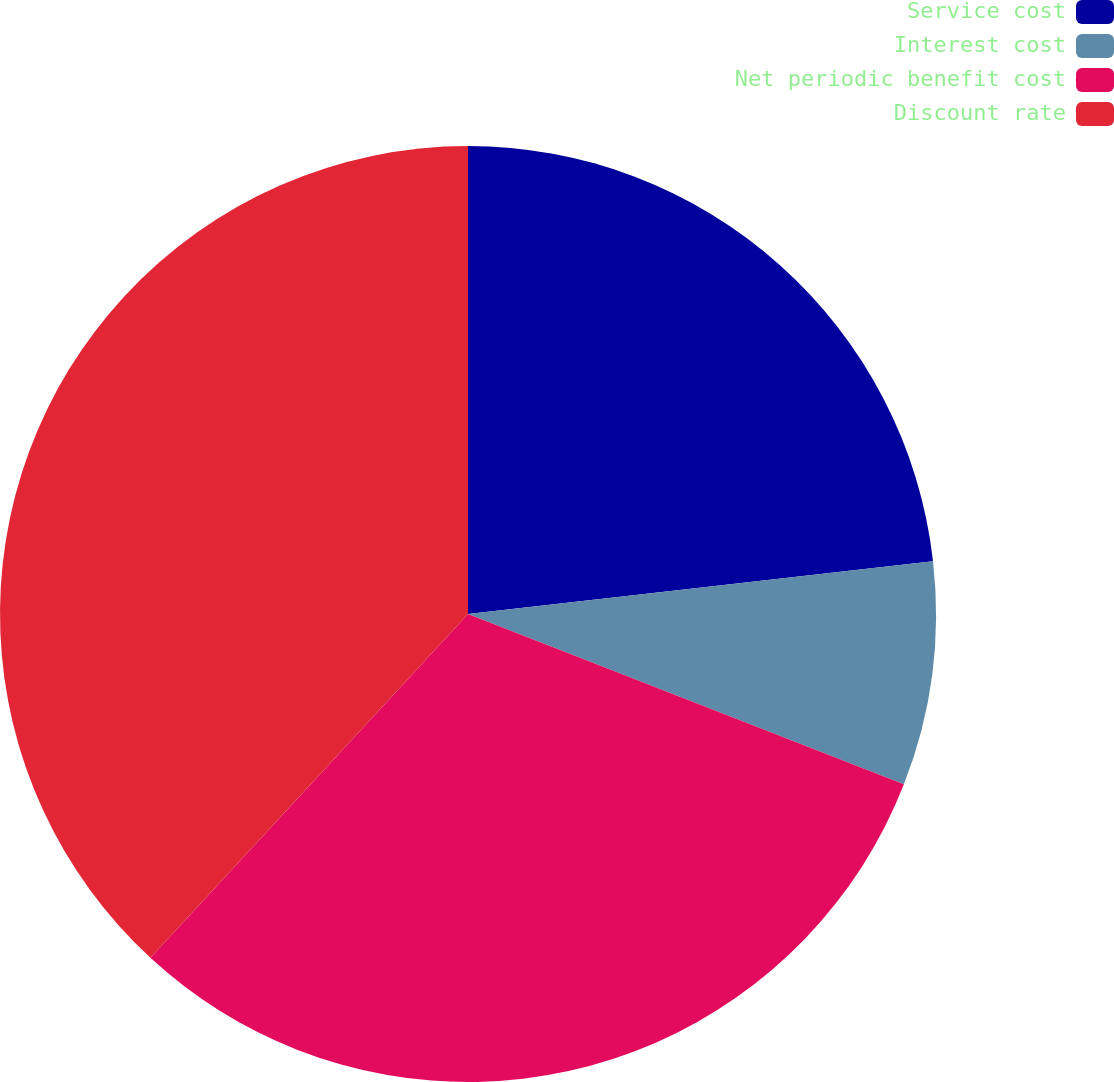Convert chart. <chart><loc_0><loc_0><loc_500><loc_500><pie_chart><fcel>Service cost<fcel>Interest cost<fcel>Net periodic benefit cost<fcel>Discount rate<nl><fcel>23.2%<fcel>7.73%<fcel>30.94%<fcel>38.13%<nl></chart> 